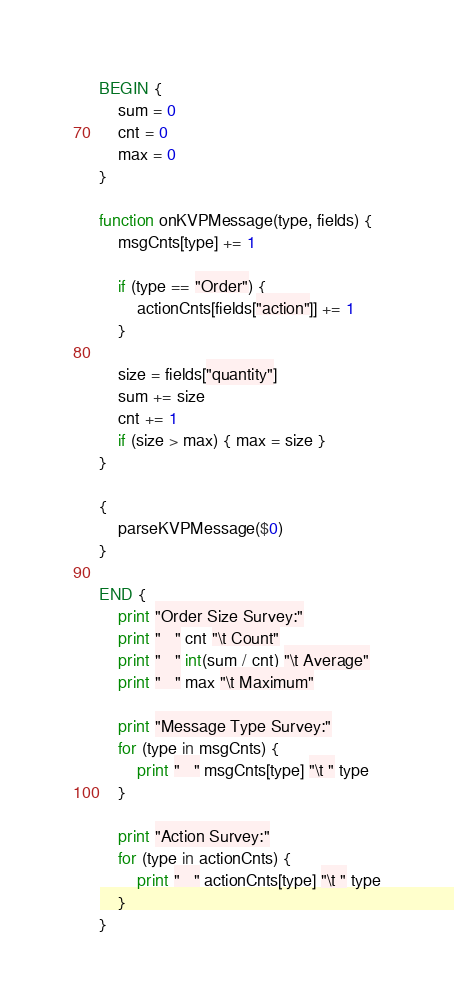Convert code to text. <code><loc_0><loc_0><loc_500><loc_500><_Awk_>
BEGIN {
    sum = 0
    cnt = 0
    max = 0
}

function onKVPMessage(type, fields) {
    msgCnts[type] += 1

    if (type == "Order") {
        actionCnts[fields["action"]] += 1
    }

    size = fields["quantity"]
    sum += size
    cnt += 1
    if (size > max) { max = size }
}

{
    parseKVPMessage($0)
}

END {
    print "Order Size Survey:"
    print "   " cnt "\t Count"
    print "   " int(sum / cnt) "\t Average"
    print "   " max "\t Maximum"

    print "Message Type Survey:"
    for (type in msgCnts) {
        print "   " msgCnts[type] "\t " type
    }

    print "Action Survey:"
    for (type in actionCnts) {
        print "   " actionCnts[type] "\t " type
    }
}
</code> 